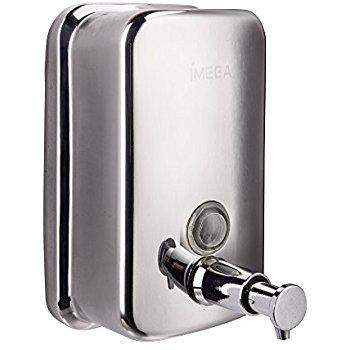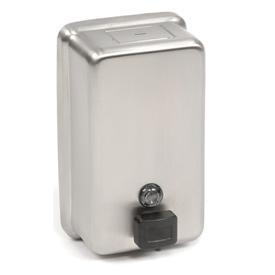The first image is the image on the left, the second image is the image on the right. Analyze the images presented: Is the assertion "The dispenser in the image on the right has a round mounting bracket." valid? Answer yes or no. No. 